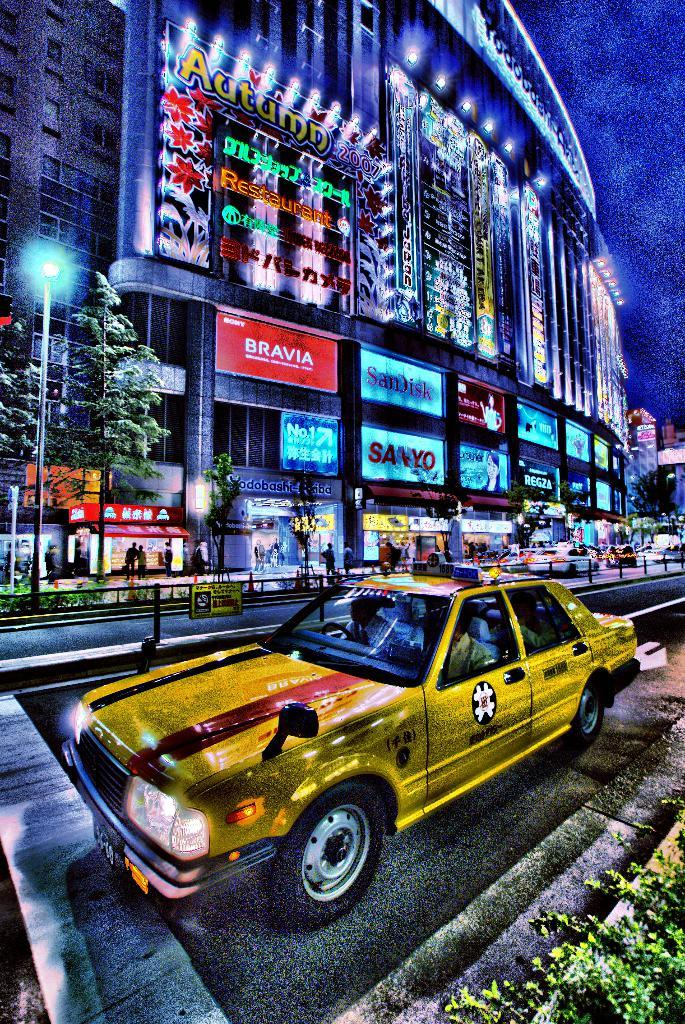<image>
Relay a brief, clear account of the picture shown. A stylized cab on street in front of a building with a lighted display of BRAVIA, SanDisk, SANYO, and Autumn. 